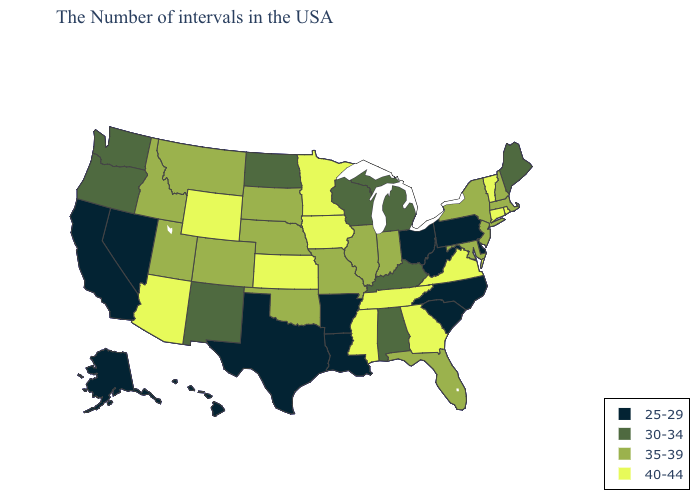What is the value of Kentucky?
Short answer required. 30-34. Name the states that have a value in the range 25-29?
Concise answer only. Delaware, Pennsylvania, North Carolina, South Carolina, West Virginia, Ohio, Louisiana, Arkansas, Texas, Nevada, California, Alaska, Hawaii. What is the highest value in the Northeast ?
Short answer required. 40-44. Name the states that have a value in the range 30-34?
Write a very short answer. Maine, Michigan, Kentucky, Alabama, Wisconsin, North Dakota, New Mexico, Washington, Oregon. How many symbols are there in the legend?
Write a very short answer. 4. Which states have the lowest value in the South?
Keep it brief. Delaware, North Carolina, South Carolina, West Virginia, Louisiana, Arkansas, Texas. Which states have the lowest value in the Northeast?
Short answer required. Pennsylvania. Among the states that border Texas , which have the lowest value?
Give a very brief answer. Louisiana, Arkansas. What is the value of Connecticut?
Answer briefly. 40-44. Does Illinois have the same value as Hawaii?
Keep it brief. No. Does Iowa have a higher value than Hawaii?
Be succinct. Yes. Does the map have missing data?
Quick response, please. No. Among the states that border Delaware , which have the lowest value?
Short answer required. Pennsylvania. Name the states that have a value in the range 25-29?
Quick response, please. Delaware, Pennsylvania, North Carolina, South Carolina, West Virginia, Ohio, Louisiana, Arkansas, Texas, Nevada, California, Alaska, Hawaii. What is the value of Vermont?
Answer briefly. 40-44. 